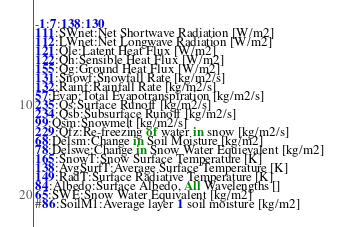<code> <loc_0><loc_0><loc_500><loc_500><_SQL_>-1:7:138:130
111:SWnet:Net Shortwave Radiation [W/m2]
112:LWnet:Net Longwave Radiation [W/m2]
121:Qle:Latent Heat Flux [W/m2]
122:Qh:Sensible Heat Flux [W/m2]
155:Qg:Ground Heat Flux [W/m2]
131:Snowf:Snowfall Rate [kg/m2/s]
132:Rainf:Rainfall Rate [kg/m2/s]
57:Evap:Total Evapotranspiration [kg/m2/s]
235:Qs:Surface Runoff [kg/m2/s]
234:Qsb:Subsurface Runoff [kg/m2/s]
99:Qsm:Snowmelt [kg/m2/s]
229:Qfz:Re-freezing of water in snow [kg/m2/s]
68:Delsm:Change in Soil Moisture [kg/m2]
78:Delswe:Change in Snow Water Equievalent [kg/m2]
165:SnowT:Snow Surface Temperature [K]
138:AvgSurfT:Average Surface Temperature [K]
149:RadT:Surface Radiative Temperature [K]
84:Albedo:Surface Albedo, All Wavelengths []
65:SWE:Snow Water Equivalent [kg/m2]
#86:SoilM1:Average layer 1 soil moisture [kg/m2]</code> 